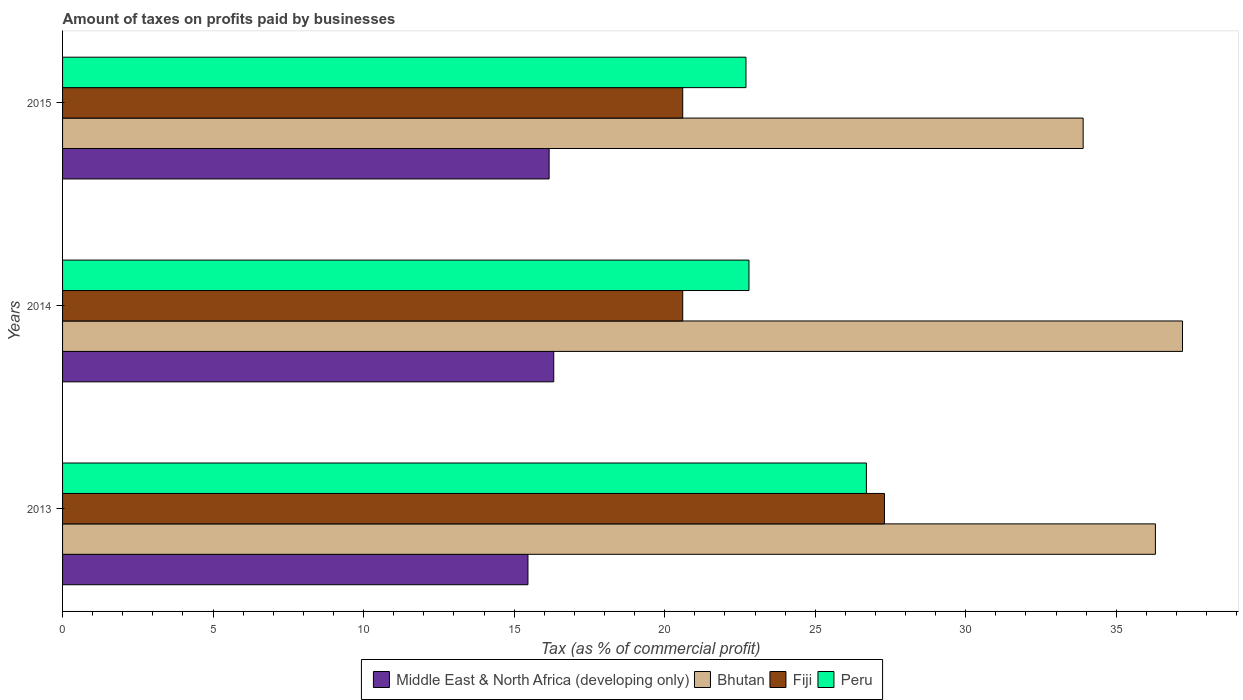How many groups of bars are there?
Offer a terse response. 3. Are the number of bars per tick equal to the number of legend labels?
Your response must be concise. Yes. Are the number of bars on each tick of the Y-axis equal?
Offer a terse response. Yes. How many bars are there on the 1st tick from the top?
Give a very brief answer. 4. How many bars are there on the 3rd tick from the bottom?
Your answer should be compact. 4. What is the label of the 1st group of bars from the top?
Offer a terse response. 2015. What is the percentage of taxes paid by businesses in Peru in 2014?
Offer a terse response. 22.8. Across all years, what is the maximum percentage of taxes paid by businesses in Peru?
Your response must be concise. 26.7. Across all years, what is the minimum percentage of taxes paid by businesses in Middle East & North Africa (developing only)?
Ensure brevity in your answer.  15.46. In which year was the percentage of taxes paid by businesses in Middle East & North Africa (developing only) minimum?
Offer a terse response. 2013. What is the total percentage of taxes paid by businesses in Middle East & North Africa (developing only) in the graph?
Your answer should be very brief. 47.94. What is the difference between the percentage of taxes paid by businesses in Middle East & North Africa (developing only) in 2014 and that in 2015?
Your answer should be compact. 0.15. What is the difference between the percentage of taxes paid by businesses in Bhutan in 2014 and the percentage of taxes paid by businesses in Middle East & North Africa (developing only) in 2015?
Your answer should be very brief. 21.04. What is the average percentage of taxes paid by businesses in Bhutan per year?
Ensure brevity in your answer.  35.8. In the year 2013, what is the difference between the percentage of taxes paid by businesses in Bhutan and percentage of taxes paid by businesses in Peru?
Ensure brevity in your answer.  9.6. In how many years, is the percentage of taxes paid by businesses in Bhutan greater than 21 %?
Your answer should be compact. 3. What is the ratio of the percentage of taxes paid by businesses in Fiji in 2013 to that in 2014?
Provide a succinct answer. 1.33. What is the difference between the highest and the second highest percentage of taxes paid by businesses in Fiji?
Make the answer very short. 6.7. What is the difference between the highest and the lowest percentage of taxes paid by businesses in Middle East & North Africa (developing only)?
Your answer should be compact. 0.86. Is the sum of the percentage of taxes paid by businesses in Middle East & North Africa (developing only) in 2013 and 2014 greater than the maximum percentage of taxes paid by businesses in Bhutan across all years?
Your answer should be compact. No. Is it the case that in every year, the sum of the percentage of taxes paid by businesses in Fiji and percentage of taxes paid by businesses in Middle East & North Africa (developing only) is greater than the sum of percentage of taxes paid by businesses in Peru and percentage of taxes paid by businesses in Bhutan?
Give a very brief answer. No. What does the 3rd bar from the top in 2015 represents?
Make the answer very short. Bhutan. What does the 1st bar from the bottom in 2014 represents?
Make the answer very short. Middle East & North Africa (developing only). Is it the case that in every year, the sum of the percentage of taxes paid by businesses in Peru and percentage of taxes paid by businesses in Fiji is greater than the percentage of taxes paid by businesses in Middle East & North Africa (developing only)?
Ensure brevity in your answer.  Yes. How many bars are there?
Your response must be concise. 12. How many years are there in the graph?
Your answer should be very brief. 3. What is the difference between two consecutive major ticks on the X-axis?
Your response must be concise. 5. Are the values on the major ticks of X-axis written in scientific E-notation?
Your response must be concise. No. Does the graph contain any zero values?
Your answer should be very brief. No. Does the graph contain grids?
Your response must be concise. No. What is the title of the graph?
Make the answer very short. Amount of taxes on profits paid by businesses. Does "Puerto Rico" appear as one of the legend labels in the graph?
Your answer should be very brief. No. What is the label or title of the X-axis?
Provide a short and direct response. Tax (as % of commercial profit). What is the Tax (as % of commercial profit) of Middle East & North Africa (developing only) in 2013?
Your answer should be very brief. 15.46. What is the Tax (as % of commercial profit) in Bhutan in 2013?
Keep it short and to the point. 36.3. What is the Tax (as % of commercial profit) of Fiji in 2013?
Your response must be concise. 27.3. What is the Tax (as % of commercial profit) in Peru in 2013?
Your answer should be compact. 26.7. What is the Tax (as % of commercial profit) of Middle East & North Africa (developing only) in 2014?
Give a very brief answer. 16.32. What is the Tax (as % of commercial profit) in Bhutan in 2014?
Your answer should be very brief. 37.2. What is the Tax (as % of commercial profit) of Fiji in 2014?
Your answer should be compact. 20.6. What is the Tax (as % of commercial profit) in Peru in 2014?
Give a very brief answer. 22.8. What is the Tax (as % of commercial profit) of Middle East & North Africa (developing only) in 2015?
Keep it short and to the point. 16.16. What is the Tax (as % of commercial profit) of Bhutan in 2015?
Make the answer very short. 33.9. What is the Tax (as % of commercial profit) of Fiji in 2015?
Offer a very short reply. 20.6. What is the Tax (as % of commercial profit) in Peru in 2015?
Provide a short and direct response. 22.7. Across all years, what is the maximum Tax (as % of commercial profit) in Middle East & North Africa (developing only)?
Provide a succinct answer. 16.32. Across all years, what is the maximum Tax (as % of commercial profit) of Bhutan?
Keep it short and to the point. 37.2. Across all years, what is the maximum Tax (as % of commercial profit) of Fiji?
Provide a short and direct response. 27.3. Across all years, what is the maximum Tax (as % of commercial profit) in Peru?
Provide a succinct answer. 26.7. Across all years, what is the minimum Tax (as % of commercial profit) in Middle East & North Africa (developing only)?
Offer a terse response. 15.46. Across all years, what is the minimum Tax (as % of commercial profit) of Bhutan?
Ensure brevity in your answer.  33.9. Across all years, what is the minimum Tax (as % of commercial profit) in Fiji?
Provide a short and direct response. 20.6. Across all years, what is the minimum Tax (as % of commercial profit) of Peru?
Your answer should be compact. 22.7. What is the total Tax (as % of commercial profit) in Middle East & North Africa (developing only) in the graph?
Offer a terse response. 47.94. What is the total Tax (as % of commercial profit) of Bhutan in the graph?
Make the answer very short. 107.4. What is the total Tax (as % of commercial profit) in Fiji in the graph?
Ensure brevity in your answer.  68.5. What is the total Tax (as % of commercial profit) of Peru in the graph?
Your response must be concise. 72.2. What is the difference between the Tax (as % of commercial profit) of Middle East & North Africa (developing only) in 2013 and that in 2014?
Your response must be concise. -0.86. What is the difference between the Tax (as % of commercial profit) in Middle East & North Africa (developing only) in 2013 and that in 2015?
Ensure brevity in your answer.  -0.7. What is the difference between the Tax (as % of commercial profit) of Peru in 2013 and that in 2015?
Offer a terse response. 4. What is the difference between the Tax (as % of commercial profit) of Middle East & North Africa (developing only) in 2014 and that in 2015?
Provide a short and direct response. 0.15. What is the difference between the Tax (as % of commercial profit) of Fiji in 2014 and that in 2015?
Your answer should be compact. 0. What is the difference between the Tax (as % of commercial profit) of Middle East & North Africa (developing only) in 2013 and the Tax (as % of commercial profit) of Bhutan in 2014?
Offer a very short reply. -21.74. What is the difference between the Tax (as % of commercial profit) in Middle East & North Africa (developing only) in 2013 and the Tax (as % of commercial profit) in Fiji in 2014?
Make the answer very short. -5.14. What is the difference between the Tax (as % of commercial profit) of Middle East & North Africa (developing only) in 2013 and the Tax (as % of commercial profit) of Peru in 2014?
Offer a terse response. -7.34. What is the difference between the Tax (as % of commercial profit) in Middle East & North Africa (developing only) in 2013 and the Tax (as % of commercial profit) in Bhutan in 2015?
Make the answer very short. -18.44. What is the difference between the Tax (as % of commercial profit) in Middle East & North Africa (developing only) in 2013 and the Tax (as % of commercial profit) in Fiji in 2015?
Give a very brief answer. -5.14. What is the difference between the Tax (as % of commercial profit) of Middle East & North Africa (developing only) in 2013 and the Tax (as % of commercial profit) of Peru in 2015?
Ensure brevity in your answer.  -7.24. What is the difference between the Tax (as % of commercial profit) of Bhutan in 2013 and the Tax (as % of commercial profit) of Fiji in 2015?
Make the answer very short. 15.7. What is the difference between the Tax (as % of commercial profit) in Bhutan in 2013 and the Tax (as % of commercial profit) in Peru in 2015?
Make the answer very short. 13.6. What is the difference between the Tax (as % of commercial profit) in Fiji in 2013 and the Tax (as % of commercial profit) in Peru in 2015?
Your answer should be compact. 4.6. What is the difference between the Tax (as % of commercial profit) in Middle East & North Africa (developing only) in 2014 and the Tax (as % of commercial profit) in Bhutan in 2015?
Offer a terse response. -17.58. What is the difference between the Tax (as % of commercial profit) in Middle East & North Africa (developing only) in 2014 and the Tax (as % of commercial profit) in Fiji in 2015?
Offer a terse response. -4.28. What is the difference between the Tax (as % of commercial profit) in Middle East & North Africa (developing only) in 2014 and the Tax (as % of commercial profit) in Peru in 2015?
Your response must be concise. -6.38. What is the difference between the Tax (as % of commercial profit) of Bhutan in 2014 and the Tax (as % of commercial profit) of Fiji in 2015?
Your answer should be compact. 16.6. What is the difference between the Tax (as % of commercial profit) of Bhutan in 2014 and the Tax (as % of commercial profit) of Peru in 2015?
Offer a terse response. 14.5. What is the average Tax (as % of commercial profit) in Middle East & North Africa (developing only) per year?
Make the answer very short. 15.98. What is the average Tax (as % of commercial profit) in Bhutan per year?
Offer a very short reply. 35.8. What is the average Tax (as % of commercial profit) in Fiji per year?
Offer a very short reply. 22.83. What is the average Tax (as % of commercial profit) of Peru per year?
Offer a very short reply. 24.07. In the year 2013, what is the difference between the Tax (as % of commercial profit) in Middle East & North Africa (developing only) and Tax (as % of commercial profit) in Bhutan?
Provide a succinct answer. -20.84. In the year 2013, what is the difference between the Tax (as % of commercial profit) of Middle East & North Africa (developing only) and Tax (as % of commercial profit) of Fiji?
Ensure brevity in your answer.  -11.84. In the year 2013, what is the difference between the Tax (as % of commercial profit) of Middle East & North Africa (developing only) and Tax (as % of commercial profit) of Peru?
Your answer should be compact. -11.24. In the year 2013, what is the difference between the Tax (as % of commercial profit) in Bhutan and Tax (as % of commercial profit) in Fiji?
Keep it short and to the point. 9. In the year 2013, what is the difference between the Tax (as % of commercial profit) of Bhutan and Tax (as % of commercial profit) of Peru?
Offer a terse response. 9.6. In the year 2014, what is the difference between the Tax (as % of commercial profit) in Middle East & North Africa (developing only) and Tax (as % of commercial profit) in Bhutan?
Give a very brief answer. -20.88. In the year 2014, what is the difference between the Tax (as % of commercial profit) in Middle East & North Africa (developing only) and Tax (as % of commercial profit) in Fiji?
Offer a terse response. -4.28. In the year 2014, what is the difference between the Tax (as % of commercial profit) in Middle East & North Africa (developing only) and Tax (as % of commercial profit) in Peru?
Ensure brevity in your answer.  -6.48. In the year 2014, what is the difference between the Tax (as % of commercial profit) of Bhutan and Tax (as % of commercial profit) of Fiji?
Provide a short and direct response. 16.6. In the year 2014, what is the difference between the Tax (as % of commercial profit) of Fiji and Tax (as % of commercial profit) of Peru?
Give a very brief answer. -2.2. In the year 2015, what is the difference between the Tax (as % of commercial profit) of Middle East & North Africa (developing only) and Tax (as % of commercial profit) of Bhutan?
Give a very brief answer. -17.74. In the year 2015, what is the difference between the Tax (as % of commercial profit) of Middle East & North Africa (developing only) and Tax (as % of commercial profit) of Fiji?
Provide a succinct answer. -4.44. In the year 2015, what is the difference between the Tax (as % of commercial profit) in Middle East & North Africa (developing only) and Tax (as % of commercial profit) in Peru?
Your answer should be very brief. -6.54. In the year 2015, what is the difference between the Tax (as % of commercial profit) in Bhutan and Tax (as % of commercial profit) in Fiji?
Your answer should be compact. 13.3. In the year 2015, what is the difference between the Tax (as % of commercial profit) in Fiji and Tax (as % of commercial profit) in Peru?
Give a very brief answer. -2.1. What is the ratio of the Tax (as % of commercial profit) in Middle East & North Africa (developing only) in 2013 to that in 2014?
Provide a short and direct response. 0.95. What is the ratio of the Tax (as % of commercial profit) of Bhutan in 2013 to that in 2014?
Provide a short and direct response. 0.98. What is the ratio of the Tax (as % of commercial profit) in Fiji in 2013 to that in 2014?
Ensure brevity in your answer.  1.33. What is the ratio of the Tax (as % of commercial profit) of Peru in 2013 to that in 2014?
Give a very brief answer. 1.17. What is the ratio of the Tax (as % of commercial profit) in Middle East & North Africa (developing only) in 2013 to that in 2015?
Make the answer very short. 0.96. What is the ratio of the Tax (as % of commercial profit) of Bhutan in 2013 to that in 2015?
Your answer should be compact. 1.07. What is the ratio of the Tax (as % of commercial profit) in Fiji in 2013 to that in 2015?
Provide a short and direct response. 1.33. What is the ratio of the Tax (as % of commercial profit) of Peru in 2013 to that in 2015?
Ensure brevity in your answer.  1.18. What is the ratio of the Tax (as % of commercial profit) in Middle East & North Africa (developing only) in 2014 to that in 2015?
Your answer should be very brief. 1.01. What is the ratio of the Tax (as % of commercial profit) in Bhutan in 2014 to that in 2015?
Offer a terse response. 1.1. What is the difference between the highest and the second highest Tax (as % of commercial profit) of Middle East & North Africa (developing only)?
Provide a short and direct response. 0.15. What is the difference between the highest and the second highest Tax (as % of commercial profit) of Bhutan?
Give a very brief answer. 0.9. What is the difference between the highest and the second highest Tax (as % of commercial profit) of Fiji?
Provide a short and direct response. 6.7. What is the difference between the highest and the second highest Tax (as % of commercial profit) of Peru?
Ensure brevity in your answer.  3.9. What is the difference between the highest and the lowest Tax (as % of commercial profit) in Peru?
Keep it short and to the point. 4. 